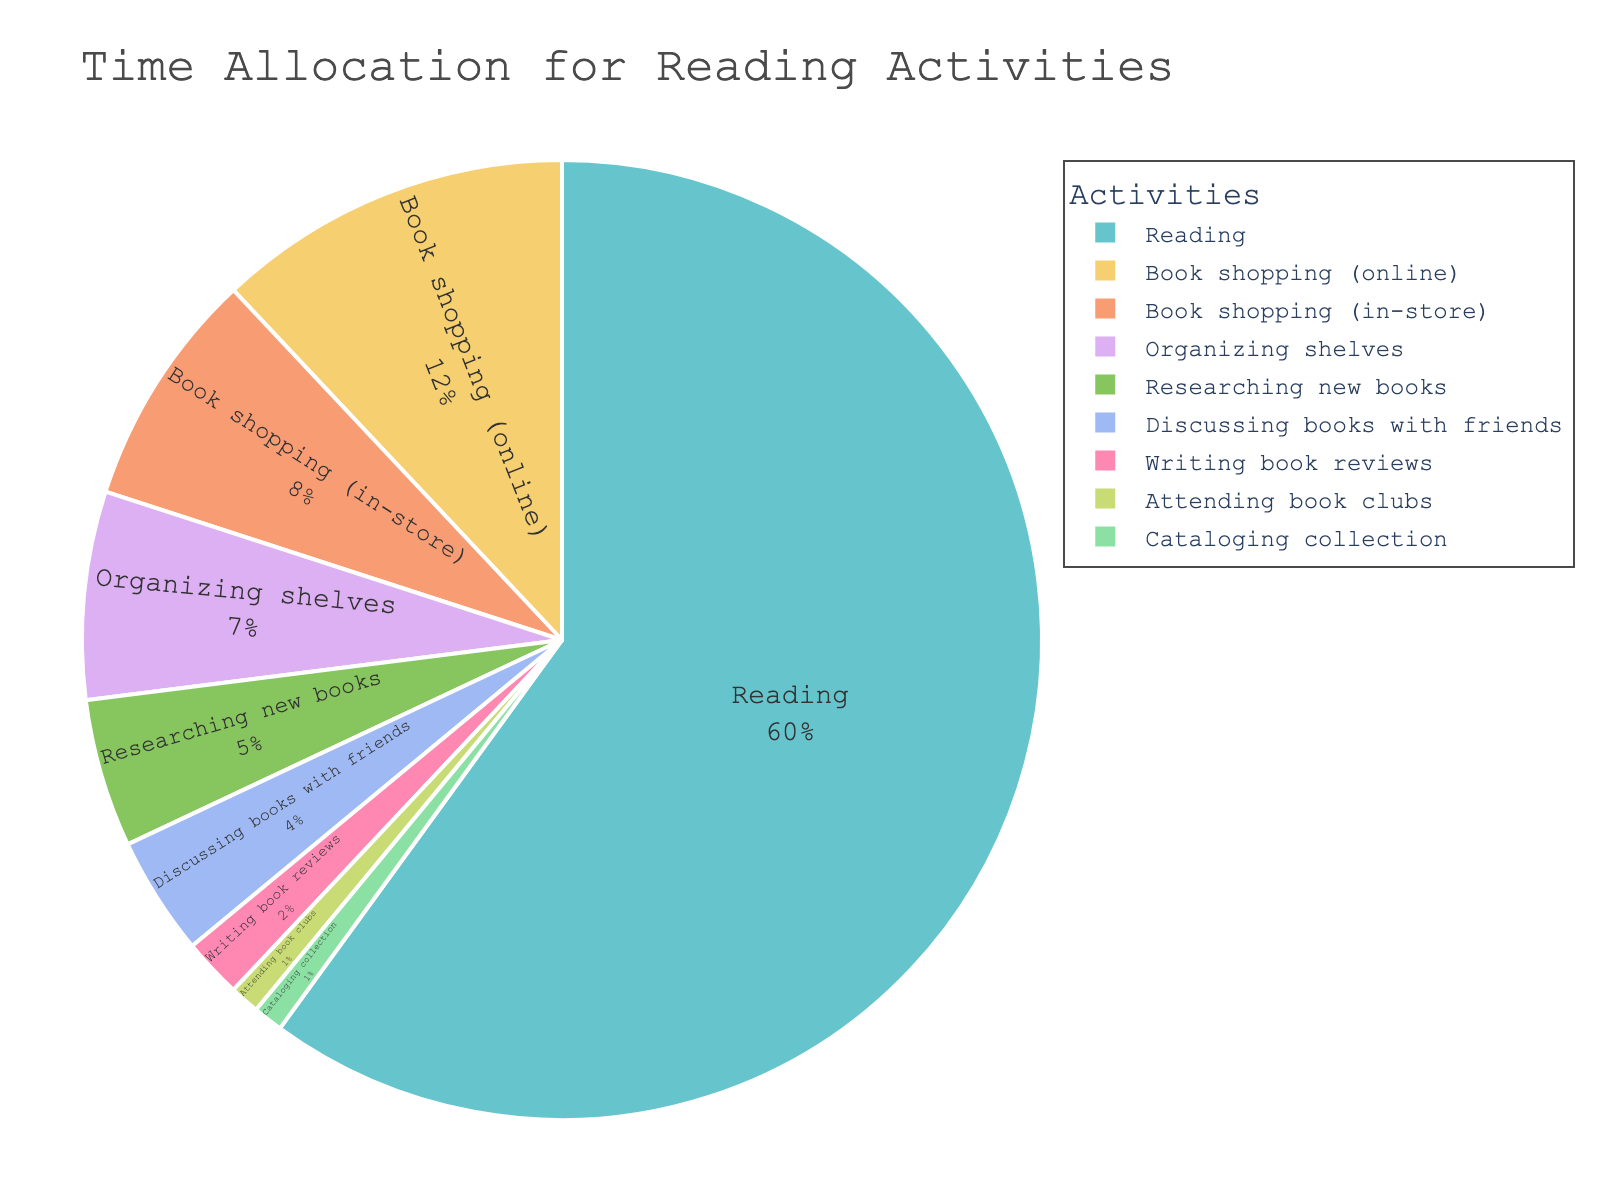Which reading activity takes up the most time? Look at the segment with the largest portion of the pie chart and see which activity it represents. Reading takes up the largest portion.
Answer: Reading What percentage of time is spent on book shopping (both online and in-store)? Add the percentage values for Book shopping (online) and Book shopping (in-store). The values are 12% + 8%. So it is 20%.
Answer: 20% How does the time spent on organizing shelves compare to that spent on writing book reviews? Compare the values for Organizing shelves and Writing book reviews. Organizing shelves is 7%, and Writing book reviews is 2%. We see that 7% is greater than 2%.
Answer: Organizing shelves is greater What is the combined percentage for all activities that are book shopping or related to book acquisition? Sum the percentages of Book shopping (online), Book shopping (in-store), Researching new books, and Cataloging collection. These values are 12% + 8% + 5% + 1%, resulting in 26%.
Answer: 26% How much more percentage of time is spent on reading compared to discussing books with friends? Subtract the percentage for Discussing books with friends from the percentage for Reading. Reading is 60% and Discussing books with friends is 4%. Thus, 60% - 4% = 56%.
Answer: 56% Is more time spent attending book clubs or cataloging the collection? Compare the values for Attending book clubs and Cataloging collection. Both activities take up 1% of the time.
Answer: Equal Which activity related to book maintenance, excluding organizing shelves, takes the least time? Look at the segments related to book maintenance and exclude Organizing shelves. These include Researching new books and Cataloging collection. Cataloging collection takes up the least time at 1%.
Answer: Cataloging collection How many times more time is spent on reading than on attending book clubs? Divide the percentage for Reading by the percentage for Attending book clubs. Reading is 60%, and Attending book clubs is 1%. So, 60 / 1 = 60 times.
Answer: 60 times What is the average time spent on book acquisition activities (shopping and researching)? Sum the relevant percentages and divide by the number of activities. The percentages are 12% + 8% + 5%. The sum is 25%, and there are 3 activities. The average is 25% / 3 = approximately 8.33%.
Answer: 8.33% Which three activities take up the smallest portions of time? Identify the three smallest segments in the pie chart. These are Attending book clubs (1%), Cataloging collection (1%), and Writing book reviews (2%).
Answer: Attending book clubs, Cataloging collection, Writing book reviews 